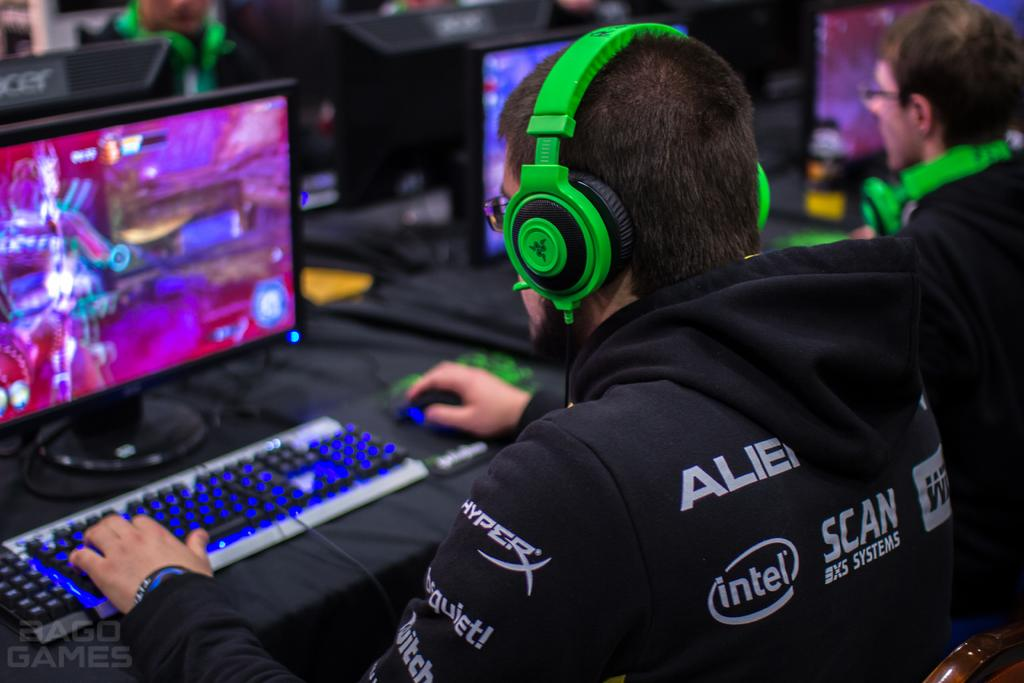<image>
Offer a succinct explanation of the picture presented. A gamer with Intel and other logos on his hoodie is playing a video game. 